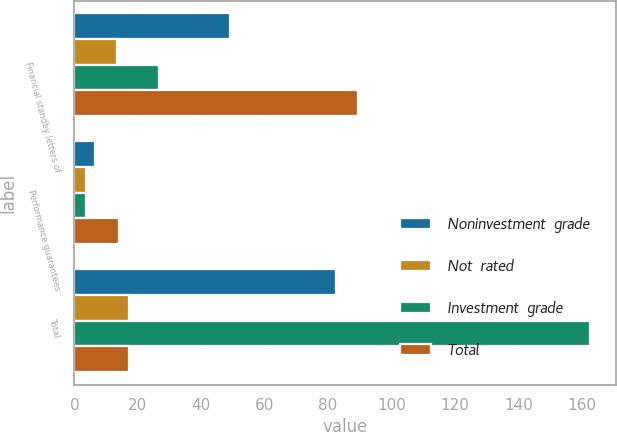Convert chart to OTSL. <chart><loc_0><loc_0><loc_500><loc_500><stacked_bar_chart><ecel><fcel>Financial standby letters of<fcel>Performance guarantees<fcel>Total<nl><fcel>Noninvestment  grade<fcel>49.2<fcel>6.5<fcel>82.4<nl><fcel>Not  rated<fcel>13.5<fcel>3.7<fcel>17.2<nl><fcel>Investment  grade<fcel>26.7<fcel>3.7<fcel>162.6<nl><fcel>Total<fcel>89.4<fcel>13.9<fcel>17.2<nl></chart> 